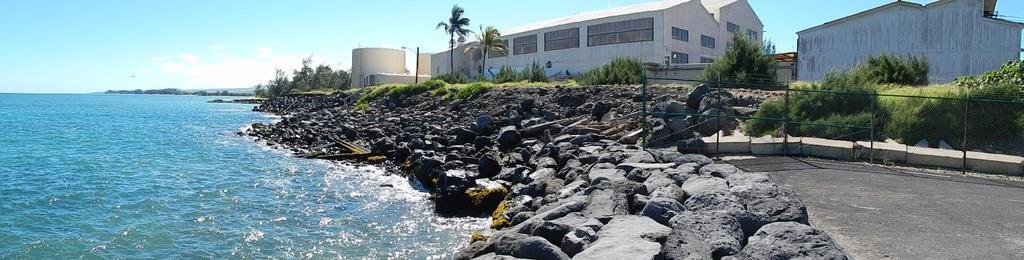Could you give a brief overview of what you see in this image? This is an outside view. In the middle of the image there are many rocks. On the left side there is an ocean. On the right side there are few buildings, trees and plants on the ground. At the top of the image I can see the sky and clouds. In the bottom right there is a road. 